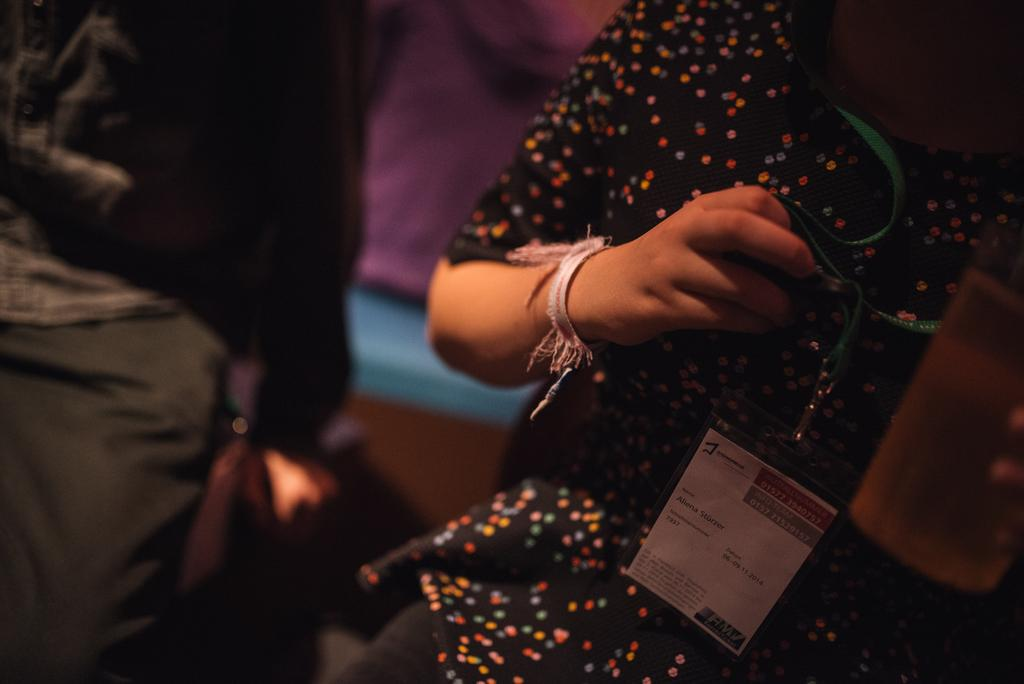Who is present in the image? There is a person in the image. What is the person holding in the image? The person is holding an ID card and a glass. Can you describe the surroundings of the person in the image? There are other people in the background of the image. What type of feather can be seen on the person's hat in the image? There is no feather present on the person's hat in the image. How many frogs are visible in the image? There are no frogs visible in the image. 